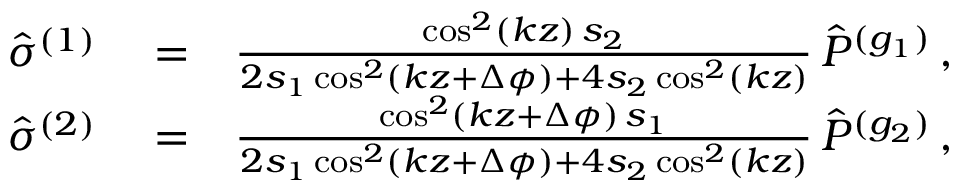Convert formula to latex. <formula><loc_0><loc_0><loc_500><loc_500>\begin{array} { r l r } { { \hat { \sigma } } ^ { ( 1 ) } } & = } & { \frac { \cos ^ { 2 } ( k z ) \, s _ { 2 } } { 2 s _ { 1 } \cos ^ { 2 } ( k z + \Delta \phi ) + 4 s _ { 2 } \cos ^ { 2 } ( k z ) } \, { \hat { P } } ^ { ( g _ { 1 } ) } \, , } \\ { { \hat { \sigma } } ^ { ( 2 ) } } & = } & { \frac { \cos ^ { 2 } ( k z + \Delta \phi ) \, s _ { 1 } } { 2 s _ { 1 } \cos ^ { 2 } ( k z + \Delta \phi ) + 4 s _ { 2 } \cos ^ { 2 } ( k z ) } \, { \hat { P } } ^ { ( g _ { 2 } ) } \, , } \end{array}</formula> 